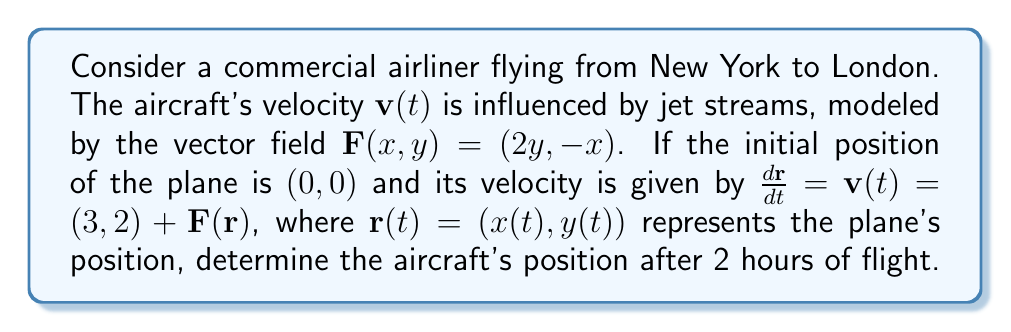Help me with this question. To solve this problem, we need to follow these steps:

1) First, we need to set up the system of differential equations:

   $$\frac{dx}{dt} = 3 + 2y$$
   $$\frac{dy}{dt} = 2 - x$$

2) This is a system of coupled first-order differential equations. We can solve it using the following steps:

3) Differentiate the first equation with respect to t:

   $$\frac{d^2x}{dt^2} = 2\frac{dy}{dt} = 2(2-x)$$

4) This gives us a second-order differential equation for x:

   $$\frac{d^2x}{dt^2} + 2x = 4$$

5) The general solution to this equation is:

   $$x(t) = 2 + A\cos(\sqrt{2}t) + B\sin(\sqrt{2}t)$$

6) We can find y(t) by substituting this into the original equation for dy/dt:

   $$y(t) = 1 - \frac{1}{\sqrt{2}}(A\sin(\sqrt{2}t) - B\cos(\sqrt{2}t))$$

7) To find A and B, we use the initial conditions. At t=0, x=0 and y=0:

   $$0 = 2 + A$$
   $$0 = 1 - \frac{B}{\sqrt{2}}$$

   This gives us A = -2 and B = $\sqrt{2}$

8) Therefore, our solutions are:

   $$x(t) = 2 - 2\cos(\sqrt{2}t) + \sqrt{2}\sin(\sqrt{2}t)$$
   $$y(t) = 1 - \sqrt{2}\sin(\sqrt{2}t) - \cos(\sqrt{2}t)$$

9) After 2 hours, t = 2. Substituting this:

   $$x(2) = 2 - 2\cos(2\sqrt{2}) + \sqrt{2}\sin(2\sqrt{2})$$
   $$y(2) = 1 - \sqrt{2}\sin(2\sqrt{2}) - \cos(2\sqrt{2})$$

10) Calculating these values (you can use a calculator):

    $$x(2) \approx 3.97$$
    $$y(2) \approx -0.84$$

Therefore, after 2 hours, the plane's position is approximately (3.97, -0.84).
Answer: (3.97, -0.84) 